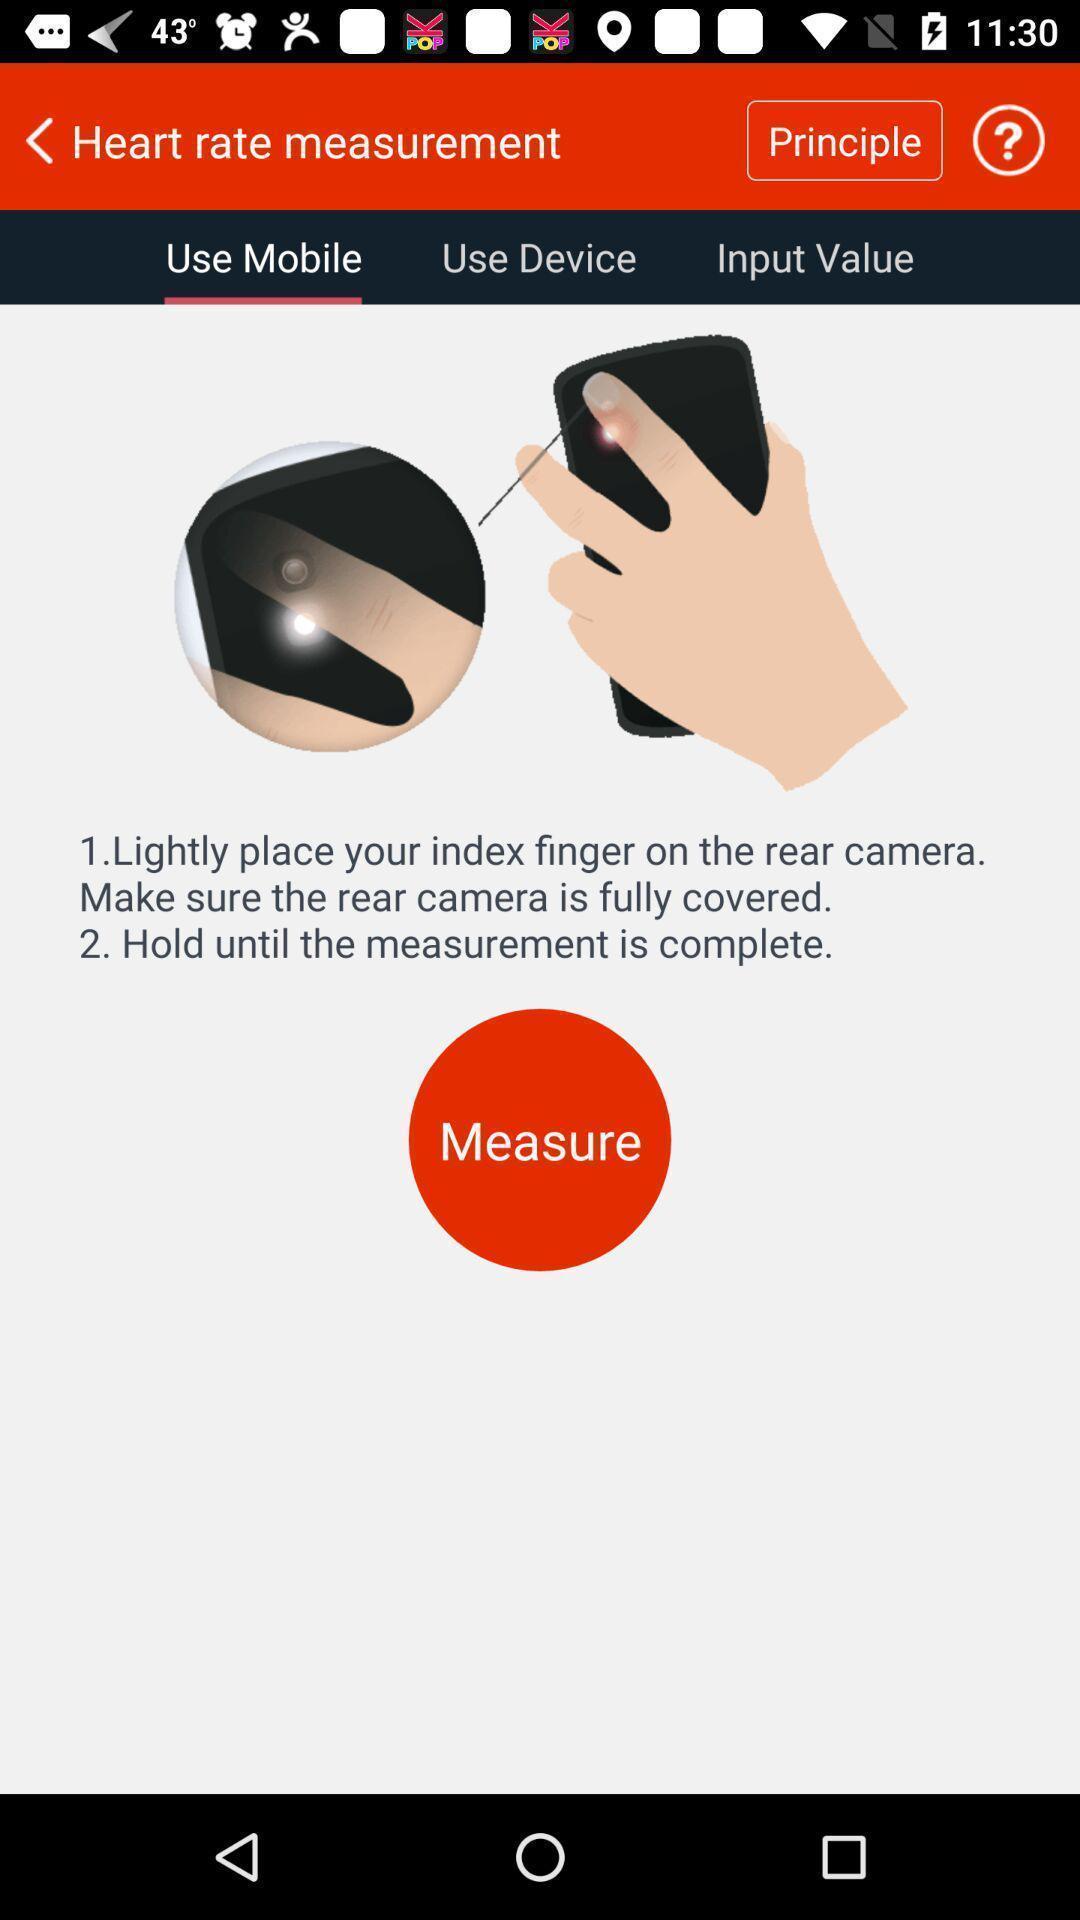Provide a description of this screenshot. Screen displaying the instructions to use mobile. 